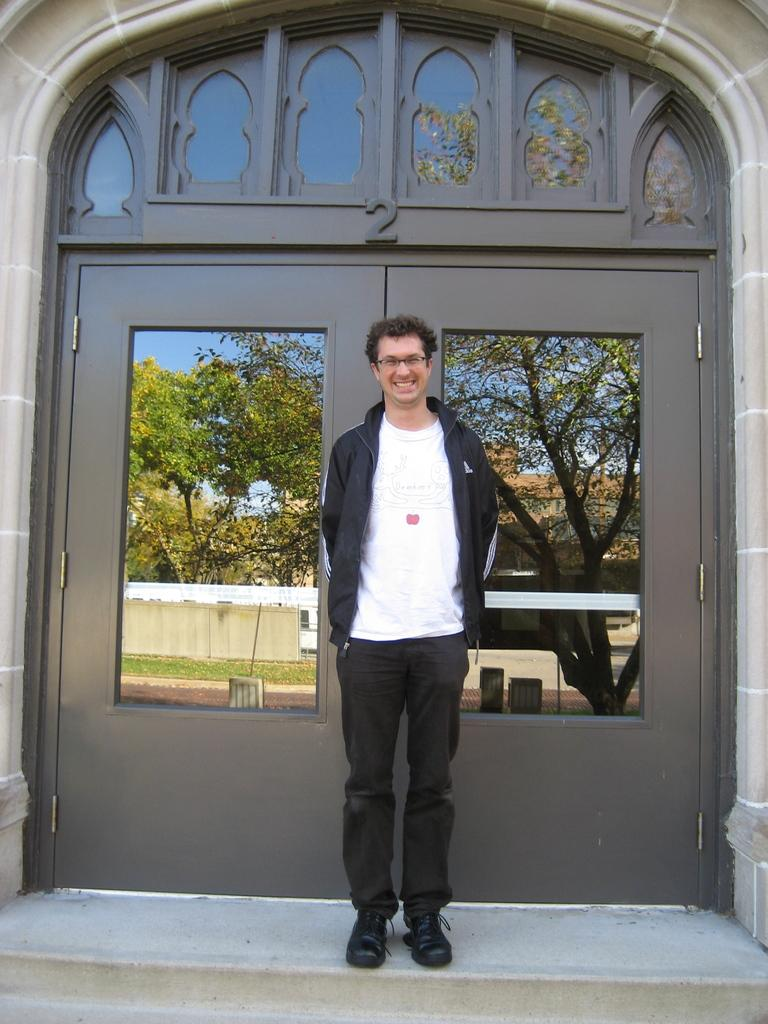What is the main subject of the image? There is a person in the image. What is the person wearing? The person is wearing a dress and spectacles. Where is the person located in the image? The person is standing on the ground. What can be seen in the background of the image? There is a building, a group of trees, and the sky visible in the background of the image. What color is the orange fan in the image? There is no orange fan present in the image. 